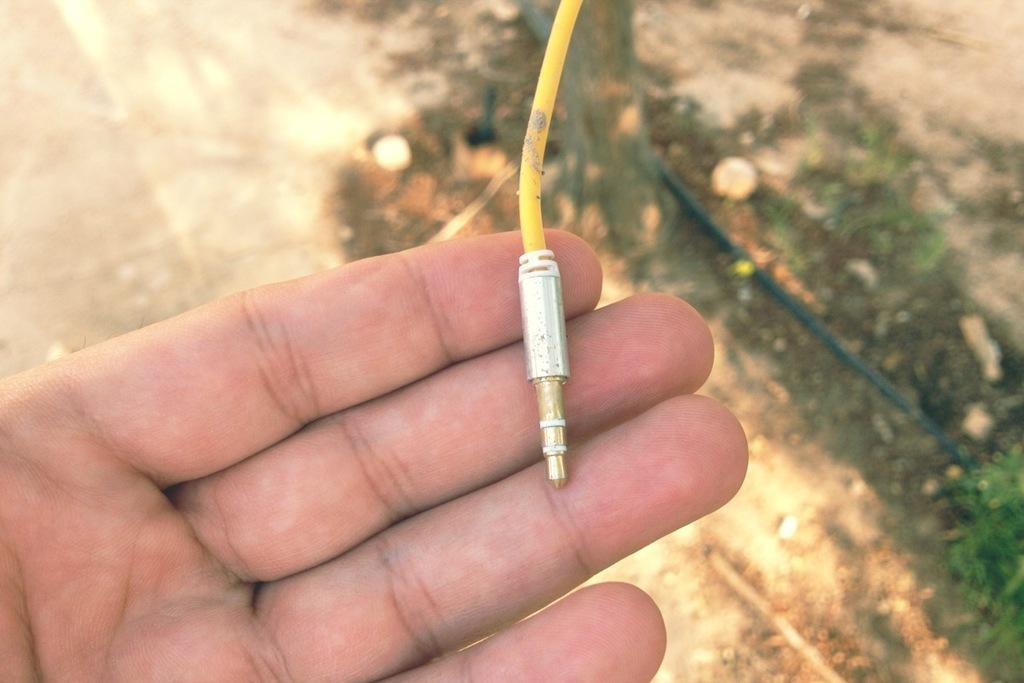What is the person's hand holding in the image? The person's hand is holding a wire on the left side of the image. What can be seen at the bottom of the image? The ground is visible at the bottom of the image, and there are plants present there. What type of engine is being used in the learning battle depicted in the image? There is no engine, learning, or battle present in the image; it only shows a person's hand holding a wire and plants at the bottom. 